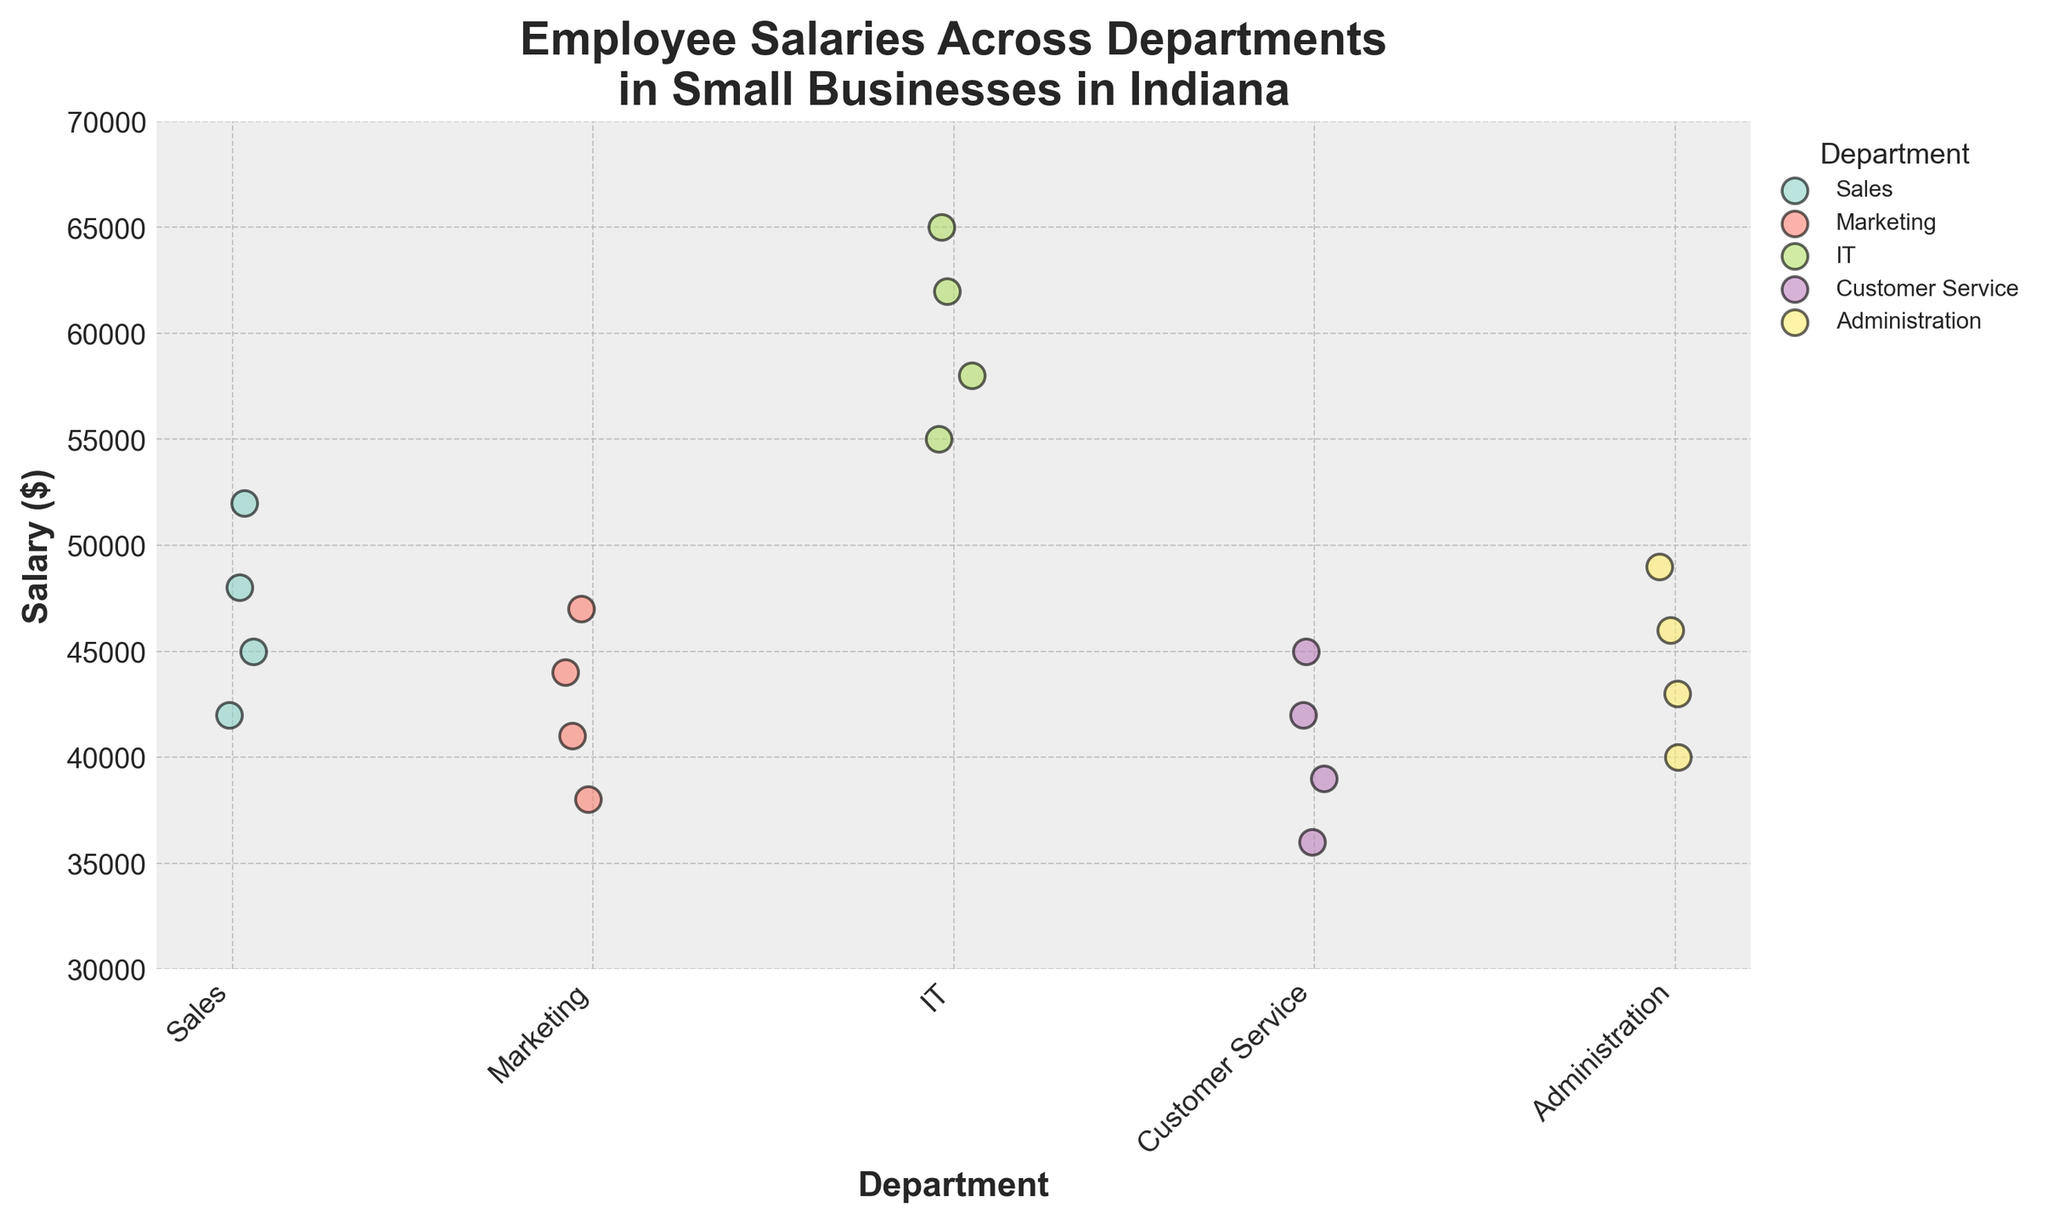What is the title of the figure? The title of the figure is often at the top, centered, and bolded to draw attention and summarize the content. In this case, the title is "Employee Salaries Across Departments in Small Businesses in Indiana."
Answer: Employee Salaries Across Departments in Small Businesses in Indiana Which department has the highest salary range? By observing the y-axis, which represents the salary and looking at the vertical spread of the points for each department, IT has the highest range (from $55,000 to $65,000).
Answer: IT How many departments are represented in the figure? The x-axis lists the departments, and there are five unique labels: Sales, Marketing, IT, Customer Service, and Administration.
Answer: Five What is the average salary for the Marketing department? The salaries in Marketing are listed as $38,000, $41,000, $44,000, and $47,000. Adding these together gives $170,000. Dividing by the number of data points (4), we calculate $170,000 / 4 = $42,500.
Answer: $42,500 Are there any departments where the lowest salary is under $40,000? One can look at the lowest point on the vertical axis (salary) for each department. Both Marketing ($38,000) and Customer Service ($36,000) have salaries under $40,000.
Answer: Marketing and Customer Service Which department has the highest individual salary and what is that salary? By looking at the highest points on the y-axis for each department, IT has the highest individual salary at $65,000.
Answer: IT, $65,000 Which department has the narrowest salary range? The narrowest range can be seen by the shortest vertical span of points. Sales has the narrowest range (from $42,000 to $52,000, for a range of $10,000).
Answer: Sales Compare the median salaries of the IT and Administration departments. Which is higher? For IT, the salaries are $55,000, $58,000, $62,000, and $65,000. The median is the average of $58,000 and $62,000, which is $60,000. For Administration, the salaries are $40,000, $43,000, $46,000, and $49,000. The median is the average of $43,000 and $46,000, which is $45,000. Thus, IT's median salary is higher.
Answer: IT Which department has more variability in salaries, Customer Service or Administration? Variability can be visually observed by the spread of points along the y-axis. Customer Service has a range from $36,000 to $45,000 ($9,000), while Administration has a range from $40,000 to $49,000 ($9,000). Both have the same range.
Answer: Same Which department appears to have the most data points? Each point represents a salary for an employee. By visually counting the points, it is clear that all departments have four data points each.
Answer: All departments are equal 